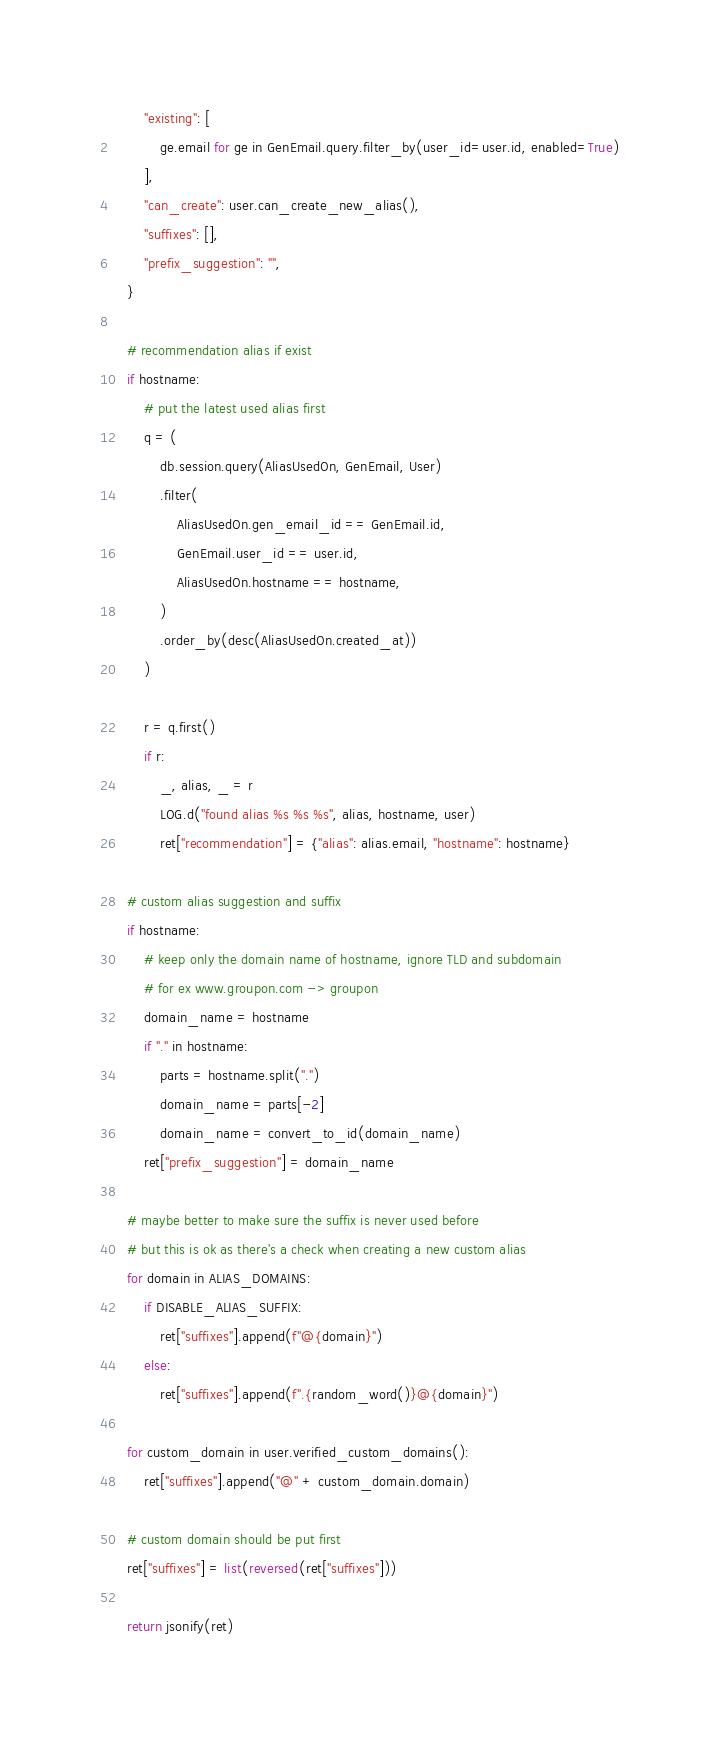Convert code to text. <code><loc_0><loc_0><loc_500><loc_500><_Python_>        "existing": [
            ge.email for ge in GenEmail.query.filter_by(user_id=user.id, enabled=True)
        ],
        "can_create": user.can_create_new_alias(),
        "suffixes": [],
        "prefix_suggestion": "",
    }

    # recommendation alias if exist
    if hostname:
        # put the latest used alias first
        q = (
            db.session.query(AliasUsedOn, GenEmail, User)
            .filter(
                AliasUsedOn.gen_email_id == GenEmail.id,
                GenEmail.user_id == user.id,
                AliasUsedOn.hostname == hostname,
            )
            .order_by(desc(AliasUsedOn.created_at))
        )

        r = q.first()
        if r:
            _, alias, _ = r
            LOG.d("found alias %s %s %s", alias, hostname, user)
            ret["recommendation"] = {"alias": alias.email, "hostname": hostname}

    # custom alias suggestion and suffix
    if hostname:
        # keep only the domain name of hostname, ignore TLD and subdomain
        # for ex www.groupon.com -> groupon
        domain_name = hostname
        if "." in hostname:
            parts = hostname.split(".")
            domain_name = parts[-2]
            domain_name = convert_to_id(domain_name)
        ret["prefix_suggestion"] = domain_name

    # maybe better to make sure the suffix is never used before
    # but this is ok as there's a check when creating a new custom alias
    for domain in ALIAS_DOMAINS:
        if DISABLE_ALIAS_SUFFIX:
            ret["suffixes"].append(f"@{domain}")
        else:
            ret["suffixes"].append(f".{random_word()}@{domain}")

    for custom_domain in user.verified_custom_domains():
        ret["suffixes"].append("@" + custom_domain.domain)

    # custom domain should be put first
    ret["suffixes"] = list(reversed(ret["suffixes"]))

    return jsonify(ret)
</code> 